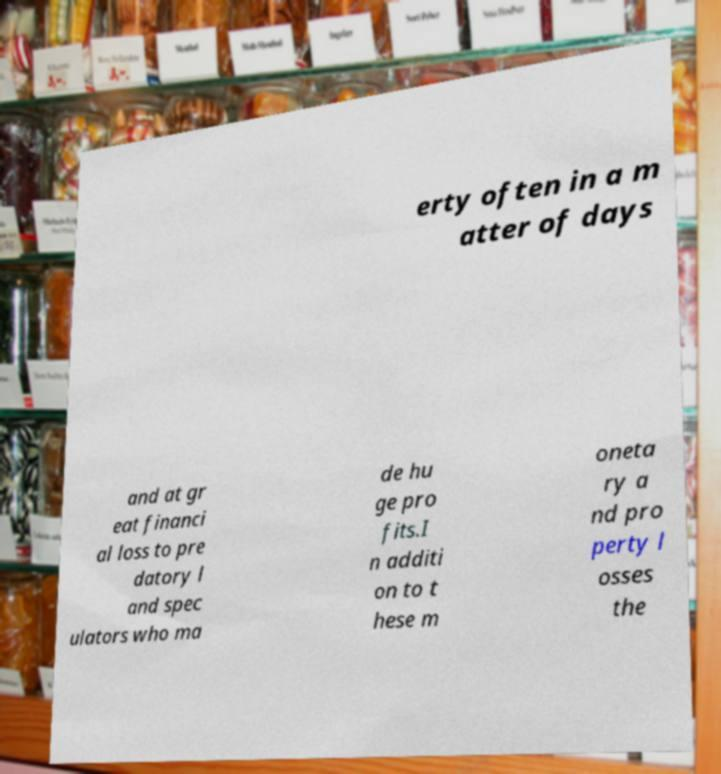I need the written content from this picture converted into text. Can you do that? erty often in a m atter of days and at gr eat financi al loss to pre datory l and spec ulators who ma de hu ge pro fits.I n additi on to t hese m oneta ry a nd pro perty l osses the 